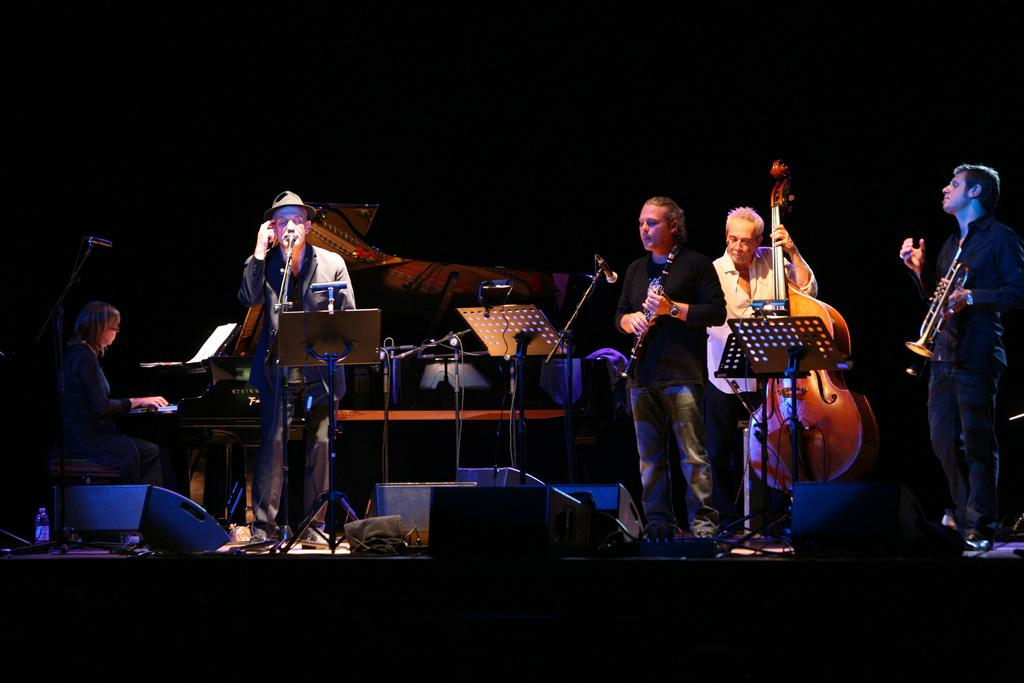What are the people in the image doing? The people in the image are playing musical instruments. What can be seen on the stage besides the musicians? There are stands and microphones (mics) in the image. Are there any other objects on the stage? Yes, there are other objects on the stage in the image. How many sheep are visible on the stage in the image? There are no sheep present on the stage in the image. What type of arithmetic problem is being solved by the musicians in the image? There is no arithmetic problem being solved by the musicians in the image; they are playing musical instruments. 